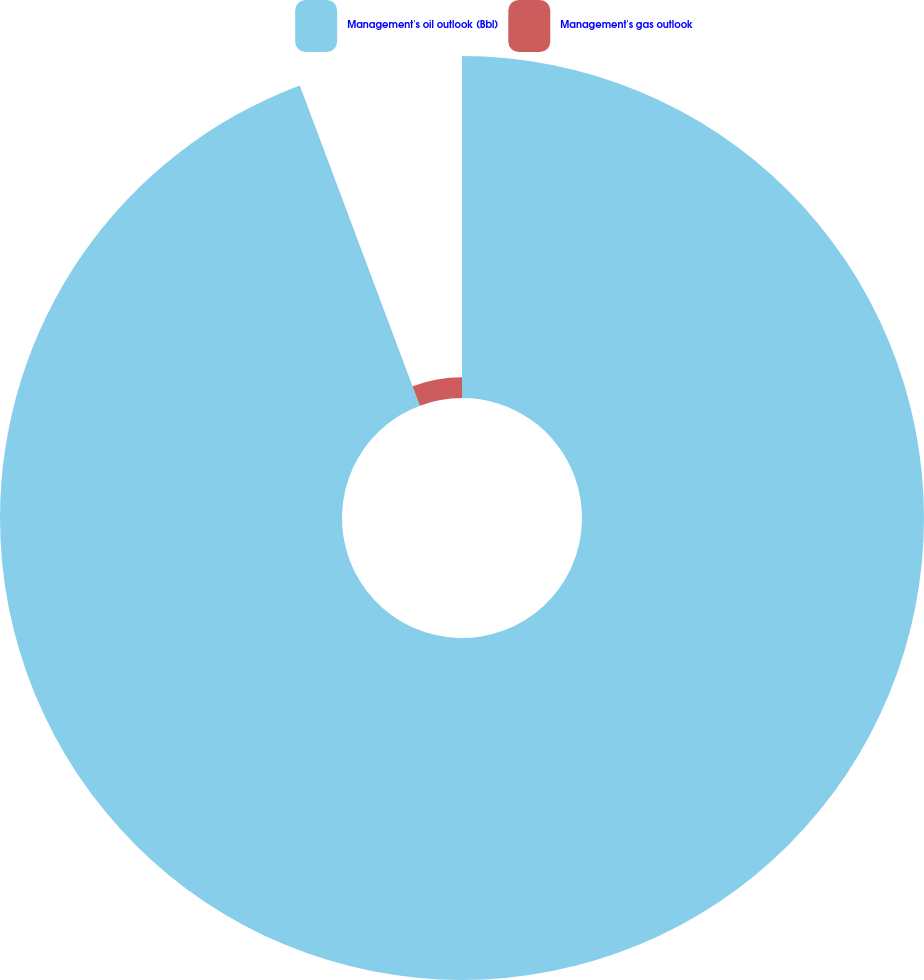<chart> <loc_0><loc_0><loc_500><loc_500><pie_chart><fcel>Management's oil outlook (Bbl)<fcel>Management's gas outlook<nl><fcel>94.29%<fcel>5.71%<nl></chart> 